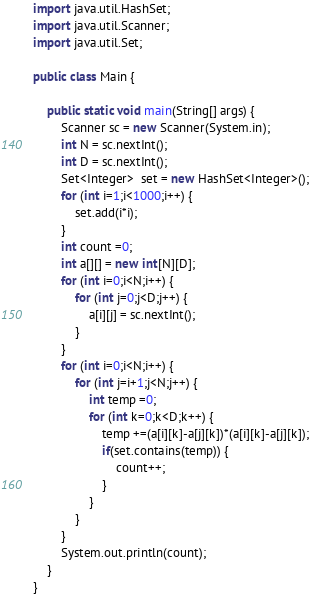Convert code to text. <code><loc_0><loc_0><loc_500><loc_500><_Java_>import java.util.HashSet;
import java.util.Scanner;
import java.util.Set;

public class Main {

	public static void main(String[] args) {
		Scanner sc = new Scanner(System.in);
		int N = sc.nextInt();
		int D = sc.nextInt();
		Set<Integer>  set = new HashSet<Integer>();
		for (int i=1;i<1000;i++) {
			set.add(i*i);
		}
		int count =0;
		int a[][] = new int[N][D];
		for (int i=0;i<N;i++) {
			for (int j=0;j<D;j++) {
				a[i][j] = sc.nextInt();
			}
		}
		for (int i=0;i<N;i++) {
			for (int j=i+1;j<N;j++) {
				int temp =0;
				for (int k=0;k<D;k++) {
					temp +=(a[i][k]-a[j][k])*(a[i][k]-a[j][k]);
					if(set.contains(temp)) {
						count++;
					}
				}
			}
		}
		System.out.println(count);
	}
}
</code> 